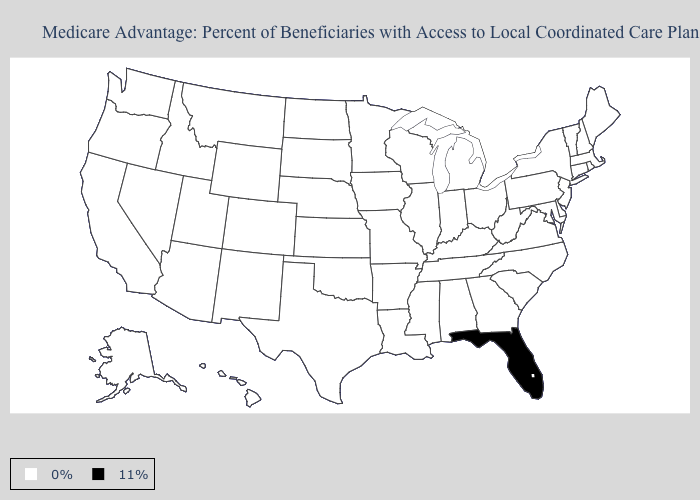What is the value of California?
Write a very short answer. 0%. What is the highest value in states that border Oregon?
Give a very brief answer. 0%. Name the states that have a value in the range 11%?
Concise answer only. Florida. What is the value of Tennessee?
Write a very short answer. 0%. Name the states that have a value in the range 0%?
Concise answer only. Alaska, Alabama, Arkansas, Arizona, California, Colorado, Connecticut, Delaware, Georgia, Hawaii, Iowa, Idaho, Illinois, Indiana, Kansas, Kentucky, Louisiana, Massachusetts, Maryland, Maine, Michigan, Minnesota, Missouri, Mississippi, Montana, North Carolina, North Dakota, Nebraska, New Hampshire, New Jersey, New Mexico, Nevada, New York, Ohio, Oklahoma, Oregon, Pennsylvania, Rhode Island, South Carolina, South Dakota, Tennessee, Texas, Utah, Virginia, Vermont, Washington, Wisconsin, West Virginia, Wyoming. What is the lowest value in states that border Oregon?
Concise answer only. 0%. How many symbols are there in the legend?
Be succinct. 2. What is the value of Nebraska?
Write a very short answer. 0%. Among the states that border Arizona , which have the lowest value?
Concise answer only. California, Colorado, New Mexico, Nevada, Utah. Does the map have missing data?
Give a very brief answer. No. What is the lowest value in the West?
Concise answer only. 0%. What is the highest value in the USA?
Keep it brief. 11%. What is the lowest value in the USA?
Answer briefly. 0%. Name the states that have a value in the range 0%?
Be succinct. Alaska, Alabama, Arkansas, Arizona, California, Colorado, Connecticut, Delaware, Georgia, Hawaii, Iowa, Idaho, Illinois, Indiana, Kansas, Kentucky, Louisiana, Massachusetts, Maryland, Maine, Michigan, Minnesota, Missouri, Mississippi, Montana, North Carolina, North Dakota, Nebraska, New Hampshire, New Jersey, New Mexico, Nevada, New York, Ohio, Oklahoma, Oregon, Pennsylvania, Rhode Island, South Carolina, South Dakota, Tennessee, Texas, Utah, Virginia, Vermont, Washington, Wisconsin, West Virginia, Wyoming. 